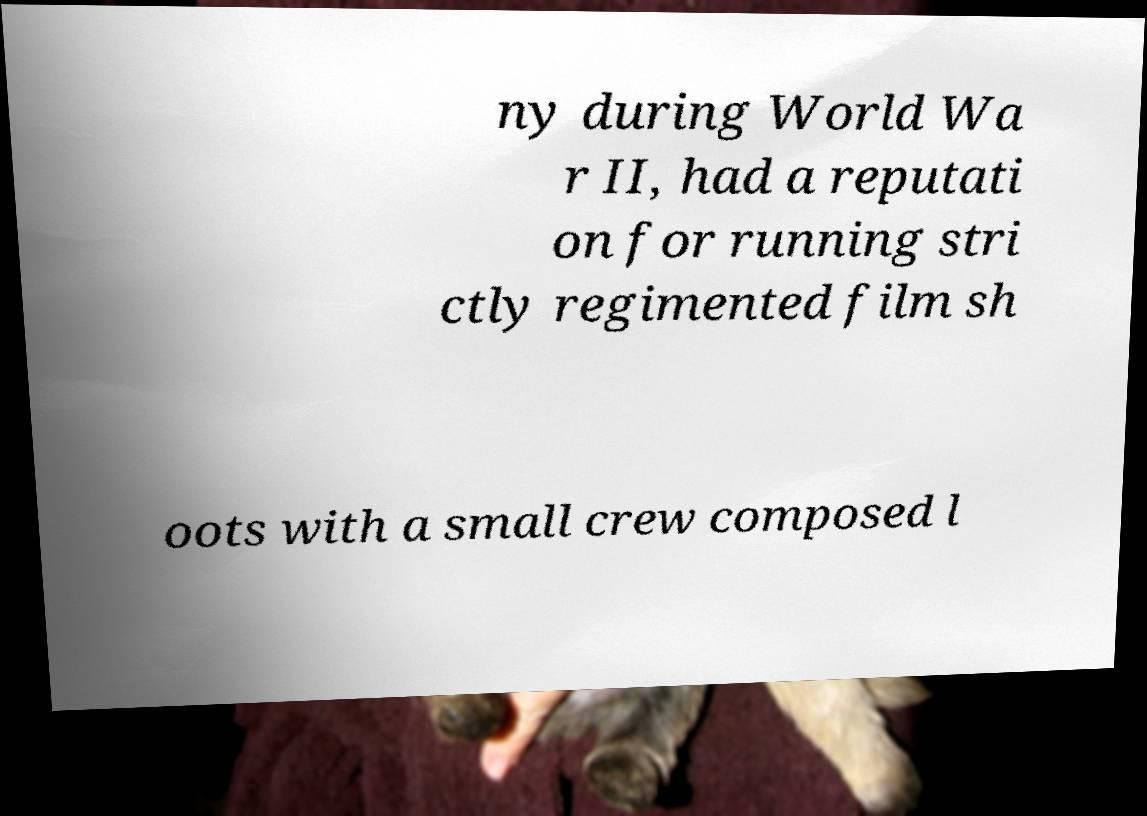Can you accurately transcribe the text from the provided image for me? ny during World Wa r II, had a reputati on for running stri ctly regimented film sh oots with a small crew composed l 